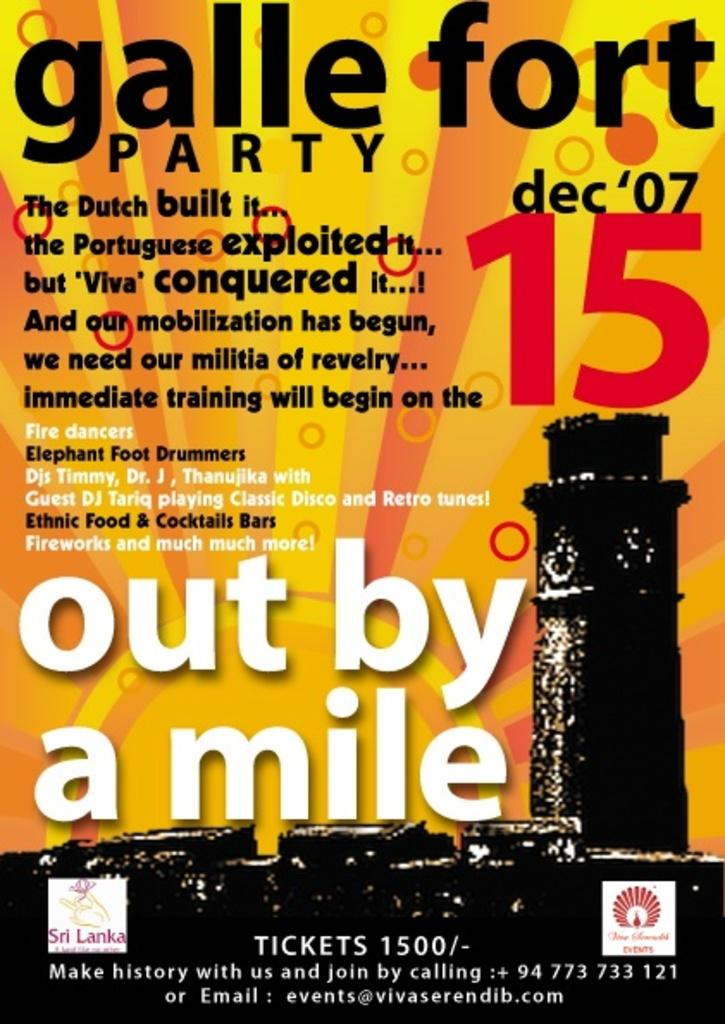<image>
Provide a brief description of the given image. Event poster with white square lower left with Sri Lanka in purple. 